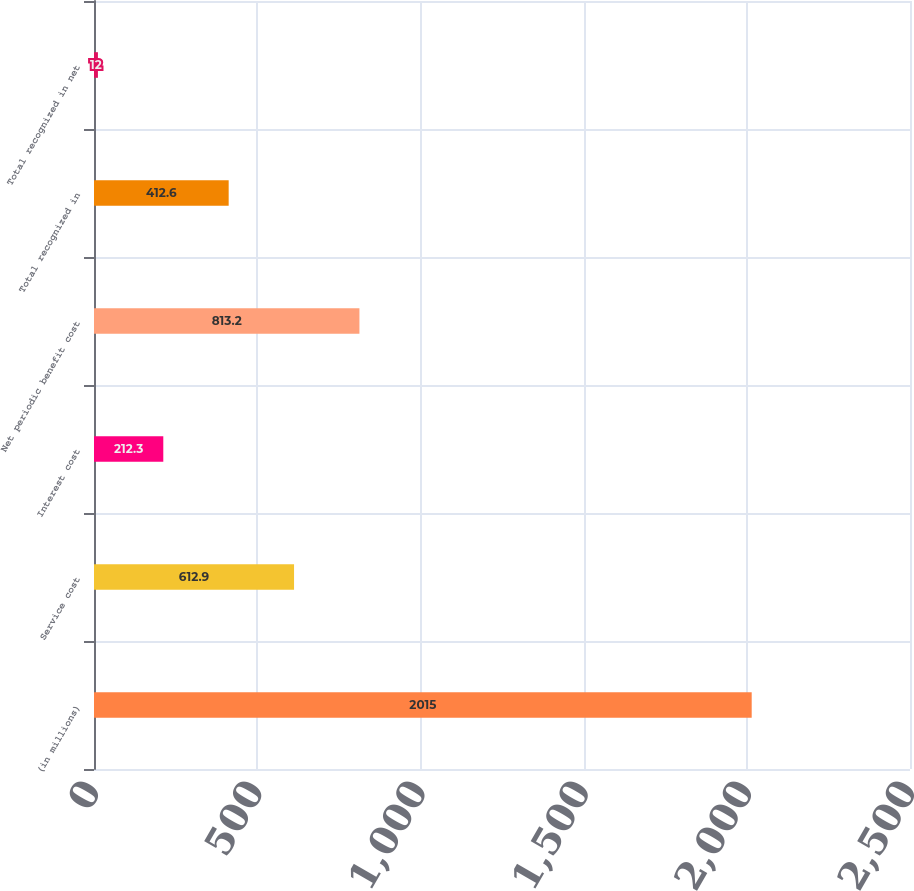<chart> <loc_0><loc_0><loc_500><loc_500><bar_chart><fcel>(in millions)<fcel>Service cost<fcel>Interest cost<fcel>Net periodic benefit cost<fcel>Total recognized in<fcel>Total recognized in net<nl><fcel>2015<fcel>612.9<fcel>212.3<fcel>813.2<fcel>412.6<fcel>12<nl></chart> 